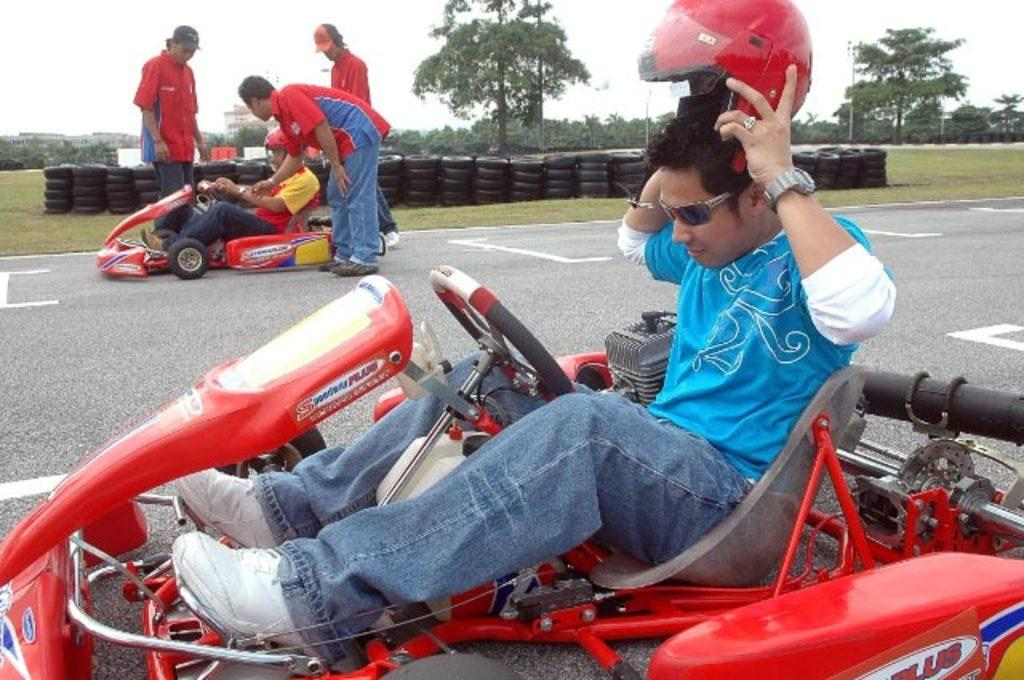How many people are sitting on the vehicle in the image? There are two persons sitting on the vehicle in the image. What safety gear is one person wearing? One person is wearing a helmet. What can be seen in the background of the image? There are trees visible in the distance. What part of the vehicle is visible in the image? There are tires in the image. How many people are standing in the image? There are three persons standing. What type of punishment is being administered to the person with the wound in the image? There is no person with a wound present in the image, and therefore no punishment is being administered. What kind of club is being used by the person in the image? There is no club present in the image. 